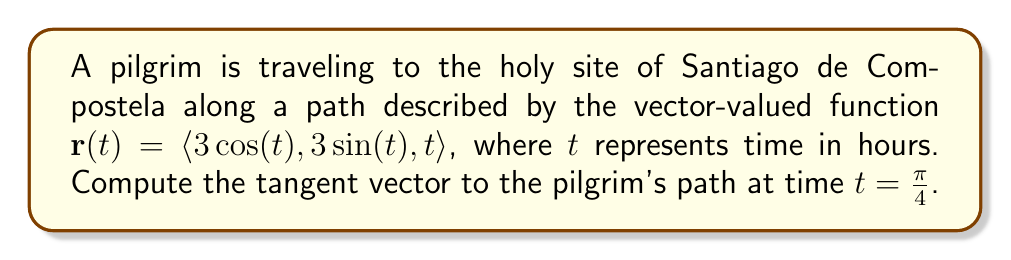What is the answer to this math problem? To find the tangent vector to the pilgrim's path, we need to calculate the derivative of the vector-valued function $\mathbf{r}(t)$ with respect to $t$. This derivative, $\mathbf{r}'(t)$, represents the velocity vector, which is tangent to the path at any given point.

1) First, let's find $\mathbf{r}'(t)$ by differentiating each component of $\mathbf{r}(t)$:

   $\mathbf{r}'(t) = \langle \frac{d}{dt}(3\cos(t)), \frac{d}{dt}(3\sin(t)), \frac{d}{dt}(t) \rangle$

2) Applying the chain rule and the fact that $\frac{d}{dt}(t) = 1$:

   $\mathbf{r}'(t) = \langle -3\sin(t), 3\cos(t), 1 \rangle$

3) Now, we need to evaluate this at $t = \frac{\pi}{4}$:

   $\mathbf{r}'(\frac{\pi}{4}) = \langle -3\sin(\frac{\pi}{4}), 3\cos(\frac{\pi}{4}), 1 \rangle$

4) Recall that $\sin(\frac{\pi}{4}) = \cos(\frac{\pi}{4}) = \frac{\sqrt{2}}{2}$:

   $\mathbf{r}'(\frac{\pi}{4}) = \langle -3\frac{\sqrt{2}}{2}, 3\frac{\sqrt{2}}{2}, 1 \rangle$

5) Simplifying:

   $\mathbf{r}'(\frac{\pi}{4}) = \langle -\frac{3\sqrt{2}}{2}, \frac{3\sqrt{2}}{2}, 1 \rangle$

This vector represents the tangent vector to the pilgrim's path at time $t = \frac{\pi}{4}$.
Answer: The tangent vector to the pilgrim's path at time $t = \frac{\pi}{4}$ is $\langle -\frac{3\sqrt{2}}{2}, \frac{3\sqrt{2}}{2}, 1 \rangle$. 